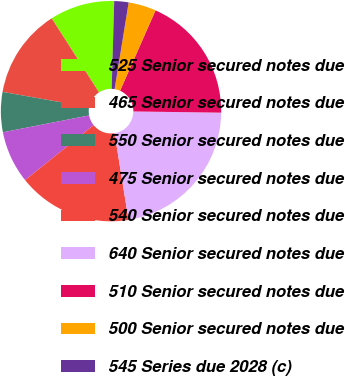<chart> <loc_0><loc_0><loc_500><loc_500><pie_chart><fcel>525 Senior secured notes due<fcel>465 Senior secured notes due<fcel>550 Senior secured notes due<fcel>475 Senior secured notes due<fcel>540 Senior secured notes due<fcel>640 Senior secured notes due<fcel>510 Senior secured notes due<fcel>500 Senior secured notes due<fcel>545 Series due 2028 (c)<nl><fcel>9.51%<fcel>13.15%<fcel>5.87%<fcel>7.69%<fcel>16.78%<fcel>22.24%<fcel>18.6%<fcel>4.06%<fcel>2.1%<nl></chart> 